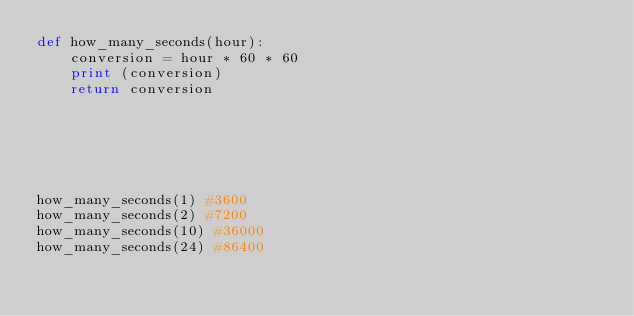Convert code to text. <code><loc_0><loc_0><loc_500><loc_500><_Python_>def how_many_seconds(hour):
    conversion = hour * 60 * 60
    print (conversion)
    return conversion
    
    
    



how_many_seconds(1) #3600
how_many_seconds(2) #7200
how_many_seconds(10) #36000
how_many_seconds(24) #86400
</code> 